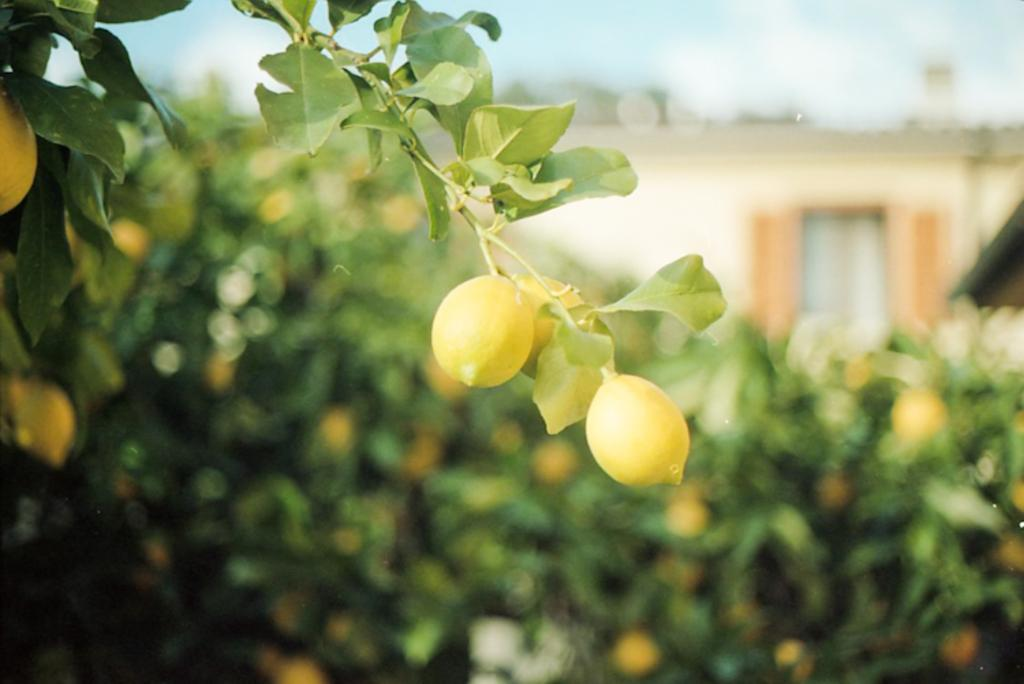What type of trees are present in the image? There are lemon trees in the image. What structure can be seen in the image? There is a building in the image. What part of the natural environment is visible in the image? The sky is visible in the image. How would you describe the background of the image? The background of the image appears blurry. What type of skin can be seen on the lemon tree's branches in the image? There is no skin visible on the lemon tree's branches in the image; only the trees and their leaves are present. 